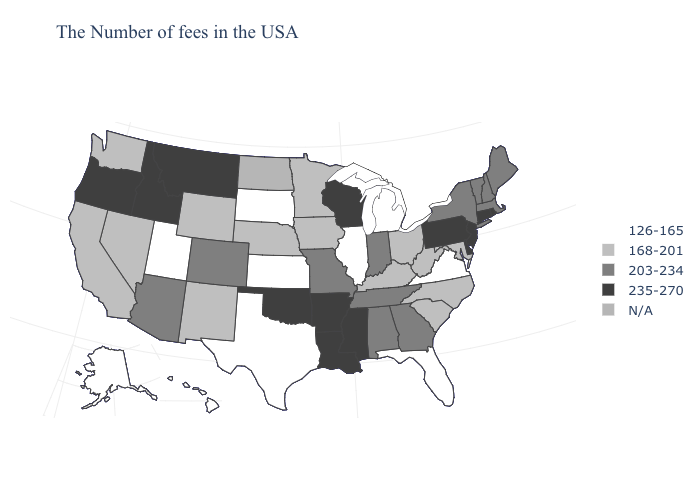What is the value of Alaska?
Write a very short answer. 126-165. What is the value of Massachusetts?
Write a very short answer. 203-234. Does New Hampshire have the lowest value in the USA?
Be succinct. No. Does New Mexico have the lowest value in the West?
Be succinct. No. Does Michigan have the lowest value in the USA?
Keep it brief. Yes. Name the states that have a value in the range N/A?
Be succinct. North Dakota. What is the value of Nevada?
Be succinct. 168-201. Among the states that border South Carolina , does Georgia have the highest value?
Concise answer only. Yes. Does Nebraska have the highest value in the MidWest?
Give a very brief answer. No. Which states hav the highest value in the MidWest?
Short answer required. Wisconsin. Which states have the lowest value in the USA?
Quick response, please. Virginia, Florida, Michigan, Illinois, Kansas, Texas, South Dakota, Utah, Alaska, Hawaii. Name the states that have a value in the range 126-165?
Be succinct. Virginia, Florida, Michigan, Illinois, Kansas, Texas, South Dakota, Utah, Alaska, Hawaii. Among the states that border North Dakota , which have the highest value?
Give a very brief answer. Montana. Which states have the lowest value in the South?
Quick response, please. Virginia, Florida, Texas. What is the highest value in states that border Mississippi?
Short answer required. 235-270. 